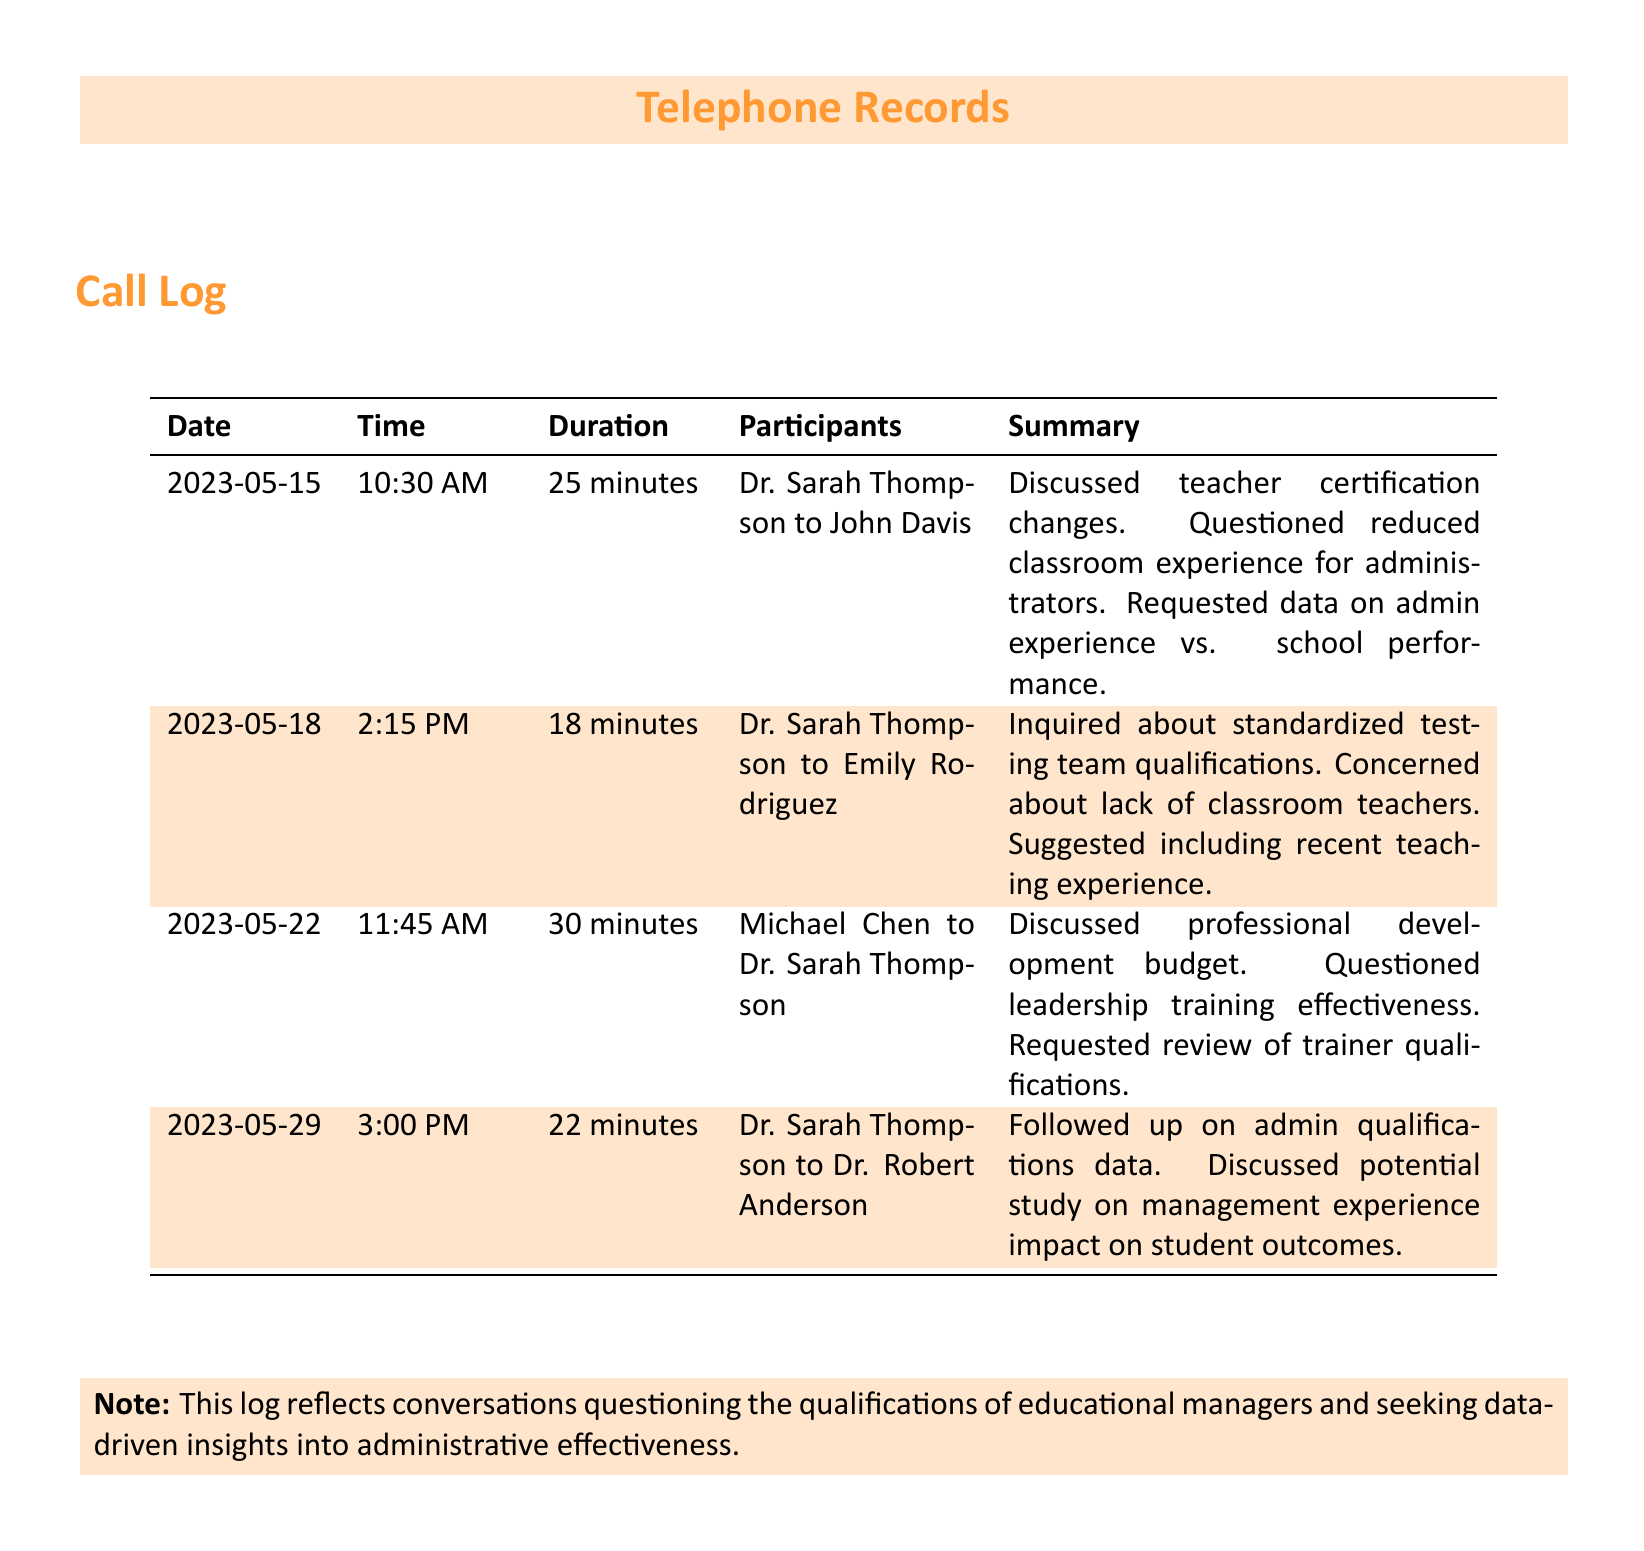What is the date of the first call? The first call occurred on May 15, 2023, as indicated in the log.
Answer: May 15, 2023 Who participated in the second call? The second call included Dr. Sarah Thompson and Emily Rodriguez, as listed in the participants column.
Answer: Dr. Sarah Thompson and Emily Rodriguez What was discussed in the call on May 29? The call on May 29 focused on admin qualifications data and management experience impact on student outcomes, according to the summary.
Answer: Admin qualifications data and management experience impact What is the duration of the longest call? The longest call is 30 minutes long, as noted in the duration column.
Answer: 30 minutes How many times was Dr. Sarah Thompson involved in calls? Dr. Sarah Thompson was involved in three separate calls, as shown in the participants column.
Answer: Three times What concern did Dr. Sarah Thompson express about classroom teachers? Dr. Sarah Thompson expressed concerns about the lack of classroom teachers in the standardized testing team, as summarized in the document.
Answer: Lack of classroom teachers What type of budget was discussed in the call with Michael Chen? The budget discussed was related to professional development, based on the summary of that call.
Answer: Professional development budget What expert qualifications were questioned in the document? The qualifications questioned were related to leadership training effectiveness and the standardized testing team.
Answer: Leadership training effectiveness and standardized testing team qualifications 